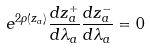<formula> <loc_0><loc_0><loc_500><loc_500>e ^ { 2 \rho ( z _ { a } ) } \frac { d z _ { a } ^ { + } } { d \lambda _ { a } } \frac { d z _ { a } ^ { - } } { d \lambda _ { a } } = 0</formula> 